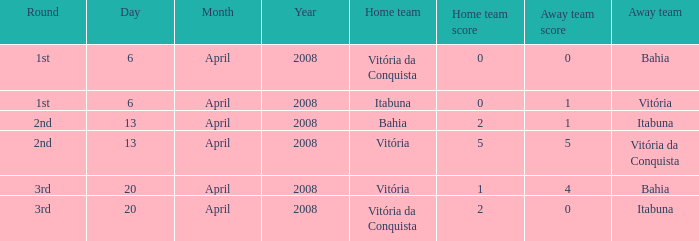What is the home team with a 5 - 5 score? Vitória. 